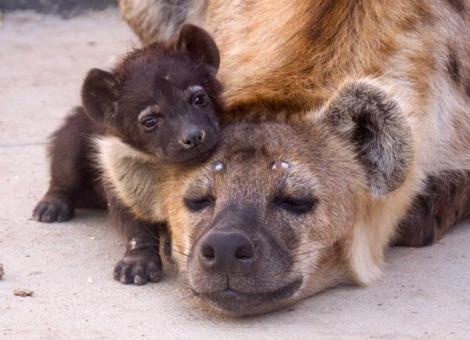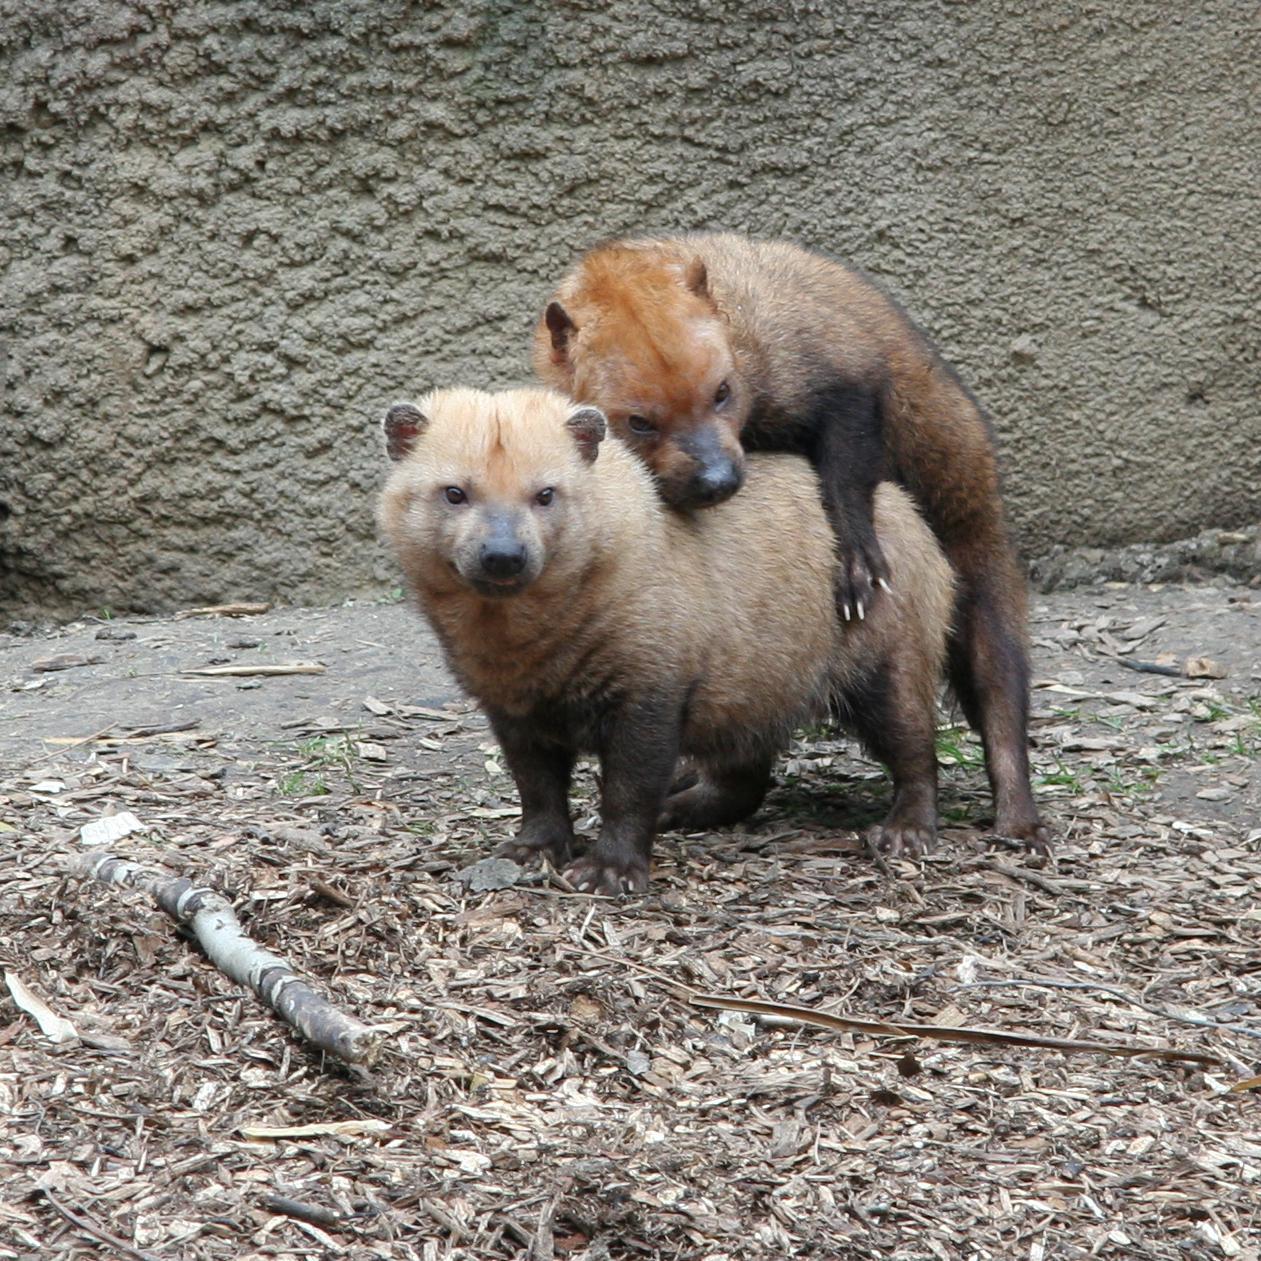The first image is the image on the left, the second image is the image on the right. Examine the images to the left and right. Is the description "A hyena has its body and face turned toward the camera." accurate? Answer yes or no. No. 